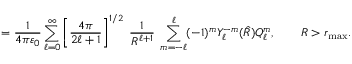<formula> <loc_0><loc_0><loc_500><loc_500>= { \frac { 1 } { 4 \pi \varepsilon _ { 0 } } } \sum _ { \ell = 0 } ^ { \infty } \left [ { \frac { 4 \pi } { 2 \ell + 1 } } \right ] ^ { 1 / 2 } \, { \frac { 1 } { R ^ { \ell + 1 } } } \, \sum _ { m = - \ell } ^ { \ell } ( - 1 ) ^ { m } Y _ { \ell } ^ { - m } ( { \hat { R } } ) Q _ { \ell } ^ { m } , \quad R > r _ { \max } .</formula> 